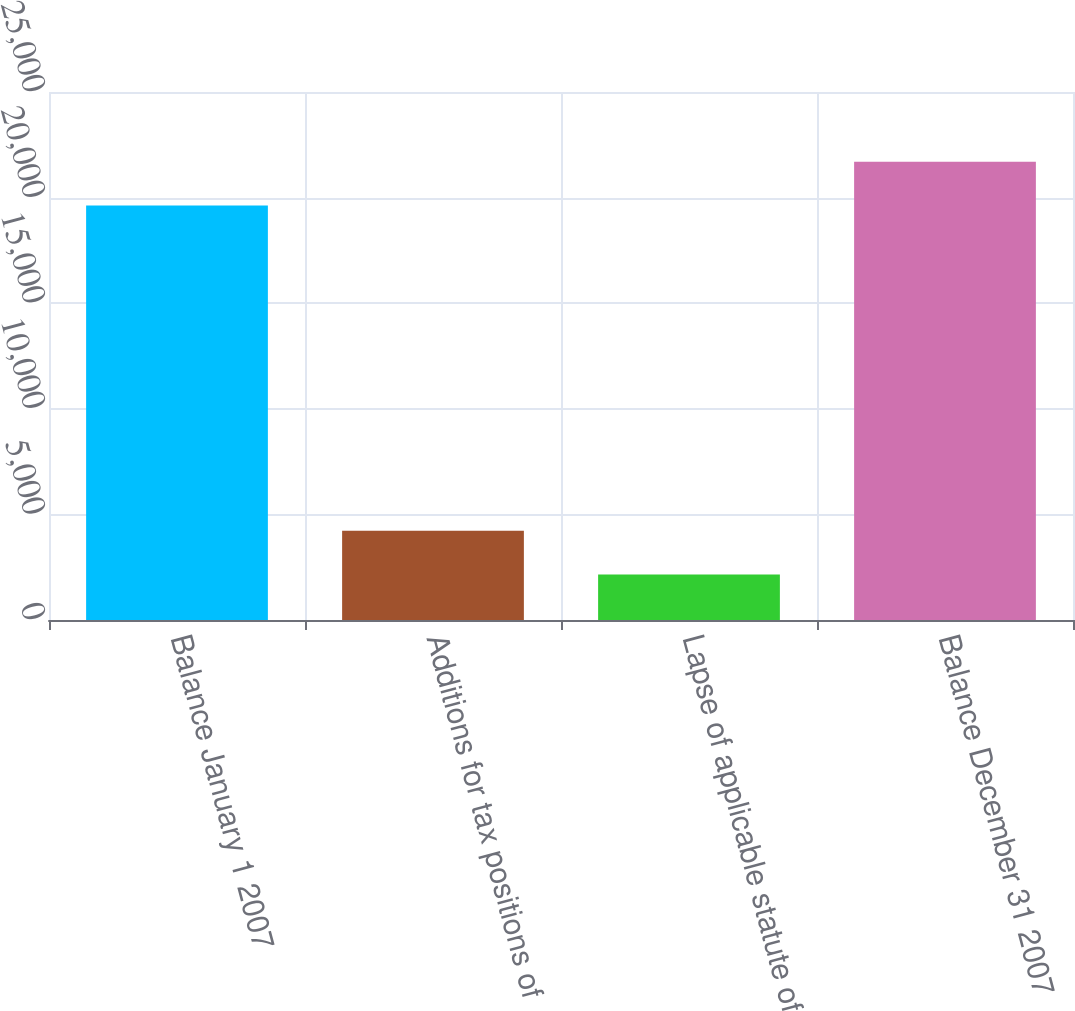Convert chart. <chart><loc_0><loc_0><loc_500><loc_500><bar_chart><fcel>Balance January 1 2007<fcel>Additions for tax positions of<fcel>Lapse of applicable statute of<fcel>Balance December 31 2007<nl><fcel>19628<fcel>4221.8<fcel>2152.9<fcel>21696.9<nl></chart> 